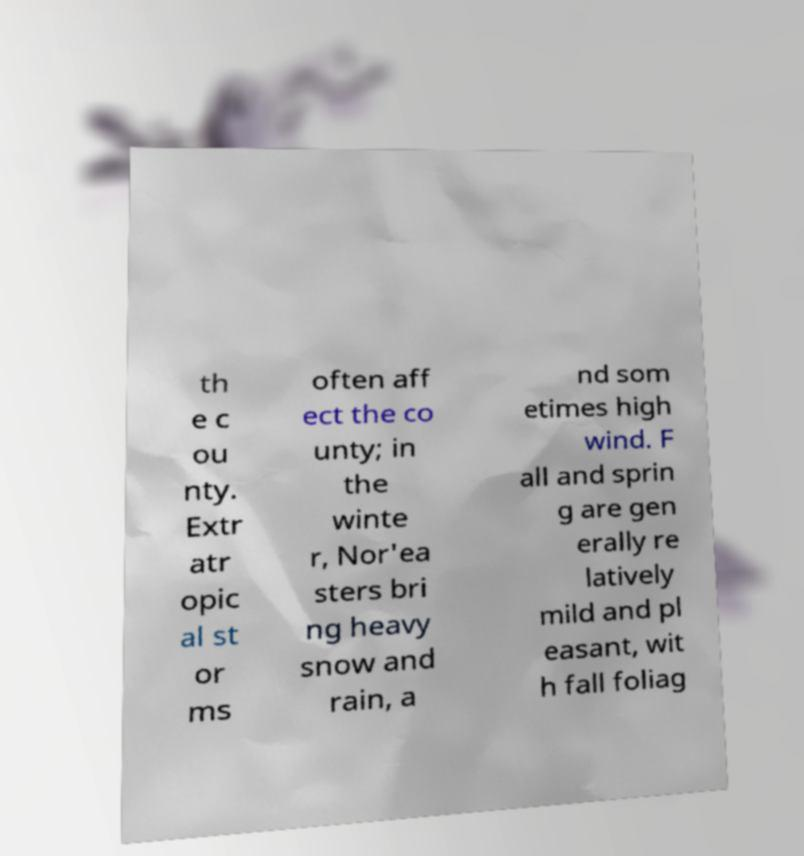Can you accurately transcribe the text from the provided image for me? th e c ou nty. Extr atr opic al st or ms often aff ect the co unty; in the winte r, Nor'ea sters bri ng heavy snow and rain, a nd som etimes high wind. F all and sprin g are gen erally re latively mild and pl easant, wit h fall foliag 